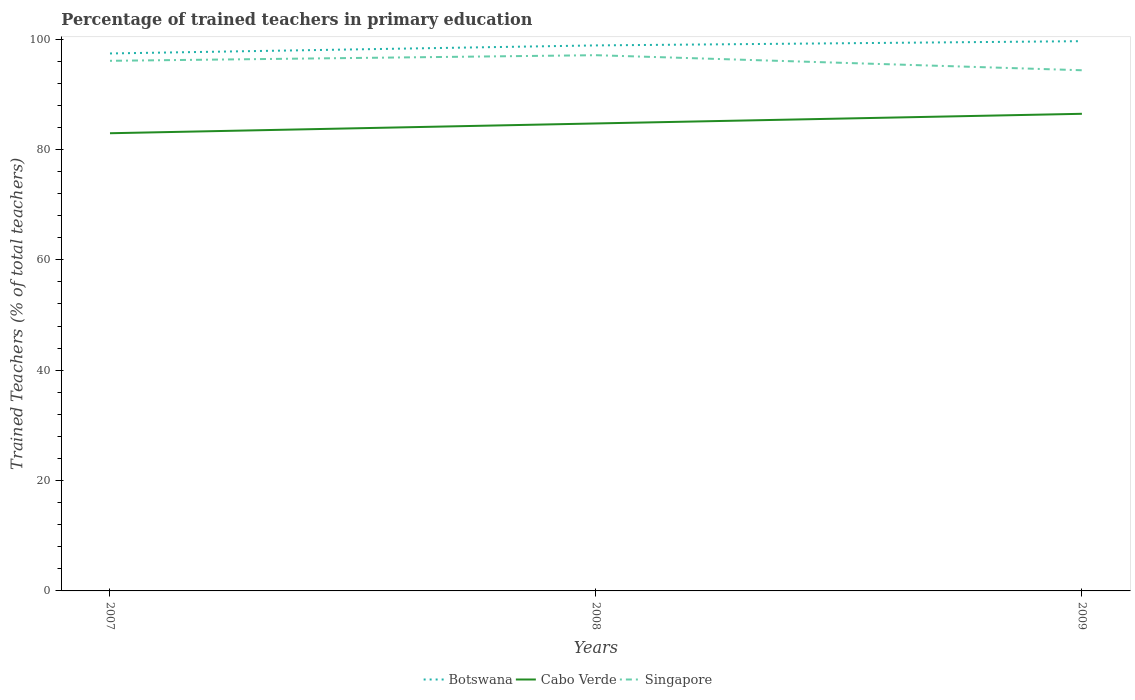How many different coloured lines are there?
Your answer should be very brief. 3. Does the line corresponding to Botswana intersect with the line corresponding to Cabo Verde?
Your response must be concise. No. Is the number of lines equal to the number of legend labels?
Your answer should be very brief. Yes. Across all years, what is the maximum percentage of trained teachers in Cabo Verde?
Your answer should be very brief. 82.93. In which year was the percentage of trained teachers in Singapore maximum?
Keep it short and to the point. 2009. What is the total percentage of trained teachers in Cabo Verde in the graph?
Your answer should be compact. -3.52. What is the difference between the highest and the second highest percentage of trained teachers in Cabo Verde?
Your answer should be very brief. 3.52. What is the difference between the highest and the lowest percentage of trained teachers in Botswana?
Provide a succinct answer. 2. How many years are there in the graph?
Your answer should be very brief. 3. Does the graph contain grids?
Your answer should be very brief. No. How are the legend labels stacked?
Keep it short and to the point. Horizontal. What is the title of the graph?
Provide a succinct answer. Percentage of trained teachers in primary education. What is the label or title of the Y-axis?
Offer a terse response. Trained Teachers (% of total teachers). What is the Trained Teachers (% of total teachers) in Botswana in 2007?
Provide a short and direct response. 97.39. What is the Trained Teachers (% of total teachers) in Cabo Verde in 2007?
Keep it short and to the point. 82.93. What is the Trained Teachers (% of total teachers) in Singapore in 2007?
Your response must be concise. 96.06. What is the Trained Teachers (% of total teachers) in Botswana in 2008?
Make the answer very short. 98.85. What is the Trained Teachers (% of total teachers) of Cabo Verde in 2008?
Offer a very short reply. 84.71. What is the Trained Teachers (% of total teachers) of Singapore in 2008?
Provide a short and direct response. 97.08. What is the Trained Teachers (% of total teachers) in Botswana in 2009?
Make the answer very short. 99.62. What is the Trained Teachers (% of total teachers) of Cabo Verde in 2009?
Provide a succinct answer. 86.46. What is the Trained Teachers (% of total teachers) in Singapore in 2009?
Your response must be concise. 94.35. Across all years, what is the maximum Trained Teachers (% of total teachers) of Botswana?
Your response must be concise. 99.62. Across all years, what is the maximum Trained Teachers (% of total teachers) in Cabo Verde?
Your response must be concise. 86.46. Across all years, what is the maximum Trained Teachers (% of total teachers) of Singapore?
Provide a succinct answer. 97.08. Across all years, what is the minimum Trained Teachers (% of total teachers) in Botswana?
Your response must be concise. 97.39. Across all years, what is the minimum Trained Teachers (% of total teachers) in Cabo Verde?
Provide a short and direct response. 82.93. Across all years, what is the minimum Trained Teachers (% of total teachers) of Singapore?
Provide a succinct answer. 94.35. What is the total Trained Teachers (% of total teachers) of Botswana in the graph?
Give a very brief answer. 295.86. What is the total Trained Teachers (% of total teachers) of Cabo Verde in the graph?
Your answer should be compact. 254.1. What is the total Trained Teachers (% of total teachers) of Singapore in the graph?
Your answer should be compact. 287.48. What is the difference between the Trained Teachers (% of total teachers) in Botswana in 2007 and that in 2008?
Give a very brief answer. -1.46. What is the difference between the Trained Teachers (% of total teachers) of Cabo Verde in 2007 and that in 2008?
Ensure brevity in your answer.  -1.77. What is the difference between the Trained Teachers (% of total teachers) in Singapore in 2007 and that in 2008?
Your answer should be very brief. -1.02. What is the difference between the Trained Teachers (% of total teachers) of Botswana in 2007 and that in 2009?
Provide a short and direct response. -2.23. What is the difference between the Trained Teachers (% of total teachers) of Cabo Verde in 2007 and that in 2009?
Make the answer very short. -3.52. What is the difference between the Trained Teachers (% of total teachers) of Singapore in 2007 and that in 2009?
Provide a succinct answer. 1.71. What is the difference between the Trained Teachers (% of total teachers) in Botswana in 2008 and that in 2009?
Give a very brief answer. -0.77. What is the difference between the Trained Teachers (% of total teachers) in Cabo Verde in 2008 and that in 2009?
Keep it short and to the point. -1.75. What is the difference between the Trained Teachers (% of total teachers) of Singapore in 2008 and that in 2009?
Your answer should be very brief. 2.73. What is the difference between the Trained Teachers (% of total teachers) of Botswana in 2007 and the Trained Teachers (% of total teachers) of Cabo Verde in 2008?
Provide a succinct answer. 12.68. What is the difference between the Trained Teachers (% of total teachers) in Botswana in 2007 and the Trained Teachers (% of total teachers) in Singapore in 2008?
Give a very brief answer. 0.31. What is the difference between the Trained Teachers (% of total teachers) of Cabo Verde in 2007 and the Trained Teachers (% of total teachers) of Singapore in 2008?
Your answer should be compact. -14.14. What is the difference between the Trained Teachers (% of total teachers) of Botswana in 2007 and the Trained Teachers (% of total teachers) of Cabo Verde in 2009?
Provide a short and direct response. 10.93. What is the difference between the Trained Teachers (% of total teachers) of Botswana in 2007 and the Trained Teachers (% of total teachers) of Singapore in 2009?
Offer a very short reply. 3.04. What is the difference between the Trained Teachers (% of total teachers) of Cabo Verde in 2007 and the Trained Teachers (% of total teachers) of Singapore in 2009?
Your answer should be compact. -11.41. What is the difference between the Trained Teachers (% of total teachers) in Botswana in 2008 and the Trained Teachers (% of total teachers) in Cabo Verde in 2009?
Provide a succinct answer. 12.39. What is the difference between the Trained Teachers (% of total teachers) in Botswana in 2008 and the Trained Teachers (% of total teachers) in Singapore in 2009?
Ensure brevity in your answer.  4.5. What is the difference between the Trained Teachers (% of total teachers) of Cabo Verde in 2008 and the Trained Teachers (% of total teachers) of Singapore in 2009?
Offer a very short reply. -9.64. What is the average Trained Teachers (% of total teachers) of Botswana per year?
Your answer should be compact. 98.62. What is the average Trained Teachers (% of total teachers) of Cabo Verde per year?
Your response must be concise. 84.7. What is the average Trained Teachers (% of total teachers) in Singapore per year?
Keep it short and to the point. 95.83. In the year 2007, what is the difference between the Trained Teachers (% of total teachers) of Botswana and Trained Teachers (% of total teachers) of Cabo Verde?
Give a very brief answer. 14.46. In the year 2007, what is the difference between the Trained Teachers (% of total teachers) of Botswana and Trained Teachers (% of total teachers) of Singapore?
Your response must be concise. 1.33. In the year 2007, what is the difference between the Trained Teachers (% of total teachers) of Cabo Verde and Trained Teachers (% of total teachers) of Singapore?
Offer a terse response. -13.13. In the year 2008, what is the difference between the Trained Teachers (% of total teachers) in Botswana and Trained Teachers (% of total teachers) in Cabo Verde?
Provide a short and direct response. 14.14. In the year 2008, what is the difference between the Trained Teachers (% of total teachers) in Botswana and Trained Teachers (% of total teachers) in Singapore?
Provide a short and direct response. 1.77. In the year 2008, what is the difference between the Trained Teachers (% of total teachers) in Cabo Verde and Trained Teachers (% of total teachers) in Singapore?
Your response must be concise. -12.37. In the year 2009, what is the difference between the Trained Teachers (% of total teachers) in Botswana and Trained Teachers (% of total teachers) in Cabo Verde?
Provide a succinct answer. 13.16. In the year 2009, what is the difference between the Trained Teachers (% of total teachers) in Botswana and Trained Teachers (% of total teachers) in Singapore?
Your answer should be compact. 5.27. In the year 2009, what is the difference between the Trained Teachers (% of total teachers) of Cabo Verde and Trained Teachers (% of total teachers) of Singapore?
Your answer should be very brief. -7.89. What is the ratio of the Trained Teachers (% of total teachers) of Botswana in 2007 to that in 2008?
Provide a short and direct response. 0.99. What is the ratio of the Trained Teachers (% of total teachers) of Cabo Verde in 2007 to that in 2008?
Provide a succinct answer. 0.98. What is the ratio of the Trained Teachers (% of total teachers) of Botswana in 2007 to that in 2009?
Ensure brevity in your answer.  0.98. What is the ratio of the Trained Teachers (% of total teachers) of Cabo Verde in 2007 to that in 2009?
Your answer should be very brief. 0.96. What is the ratio of the Trained Teachers (% of total teachers) in Singapore in 2007 to that in 2009?
Give a very brief answer. 1.02. What is the ratio of the Trained Teachers (% of total teachers) in Botswana in 2008 to that in 2009?
Your answer should be very brief. 0.99. What is the ratio of the Trained Teachers (% of total teachers) in Cabo Verde in 2008 to that in 2009?
Offer a terse response. 0.98. What is the ratio of the Trained Teachers (% of total teachers) of Singapore in 2008 to that in 2009?
Provide a succinct answer. 1.03. What is the difference between the highest and the second highest Trained Teachers (% of total teachers) of Botswana?
Offer a terse response. 0.77. What is the difference between the highest and the second highest Trained Teachers (% of total teachers) in Cabo Verde?
Ensure brevity in your answer.  1.75. What is the difference between the highest and the second highest Trained Teachers (% of total teachers) of Singapore?
Your answer should be very brief. 1.02. What is the difference between the highest and the lowest Trained Teachers (% of total teachers) in Botswana?
Offer a very short reply. 2.23. What is the difference between the highest and the lowest Trained Teachers (% of total teachers) of Cabo Verde?
Offer a very short reply. 3.52. What is the difference between the highest and the lowest Trained Teachers (% of total teachers) in Singapore?
Your answer should be compact. 2.73. 